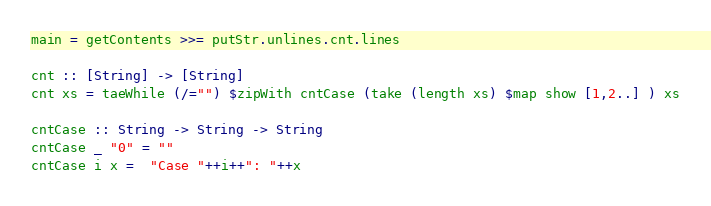Convert code to text. <code><loc_0><loc_0><loc_500><loc_500><_Haskell_>main = getContents >>= putStr.unlines.cnt.lines

cnt :: [String] -> [String]
cnt xs = taeWhile (/="") $zipWith cntCase (take (length xs) $map show [1,2..] ) xs

cntCase :: String -> String -> String
cntCase _ "0" = ""
cntCase i x =  "Case "++i++": "++x </code> 